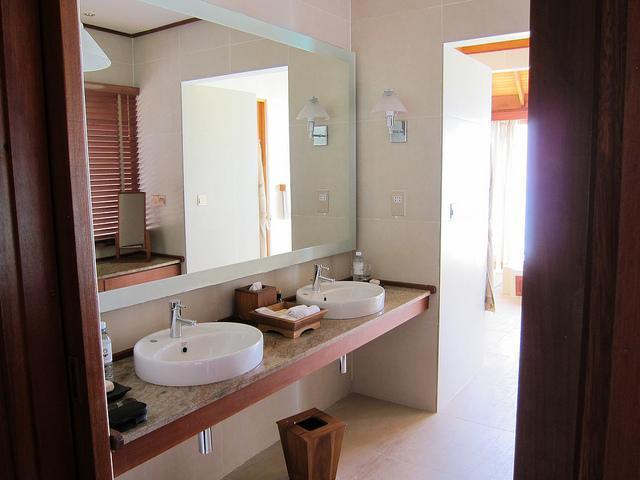How many sinks can be seen?
Give a very brief answer. 2. 